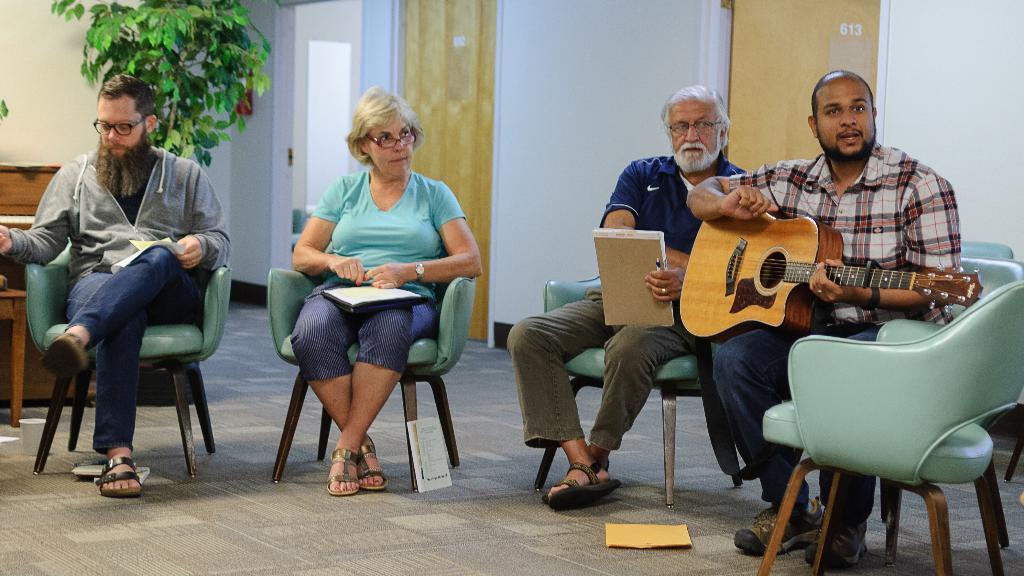Please provide a concise description of this image. In this picture we can see four people, one woman and three men and the man on the right side of the picture is holding a guitar the man behind him is holding a book, in the background we can see one plant and a door, in the bottom can we can see a book behind chair 